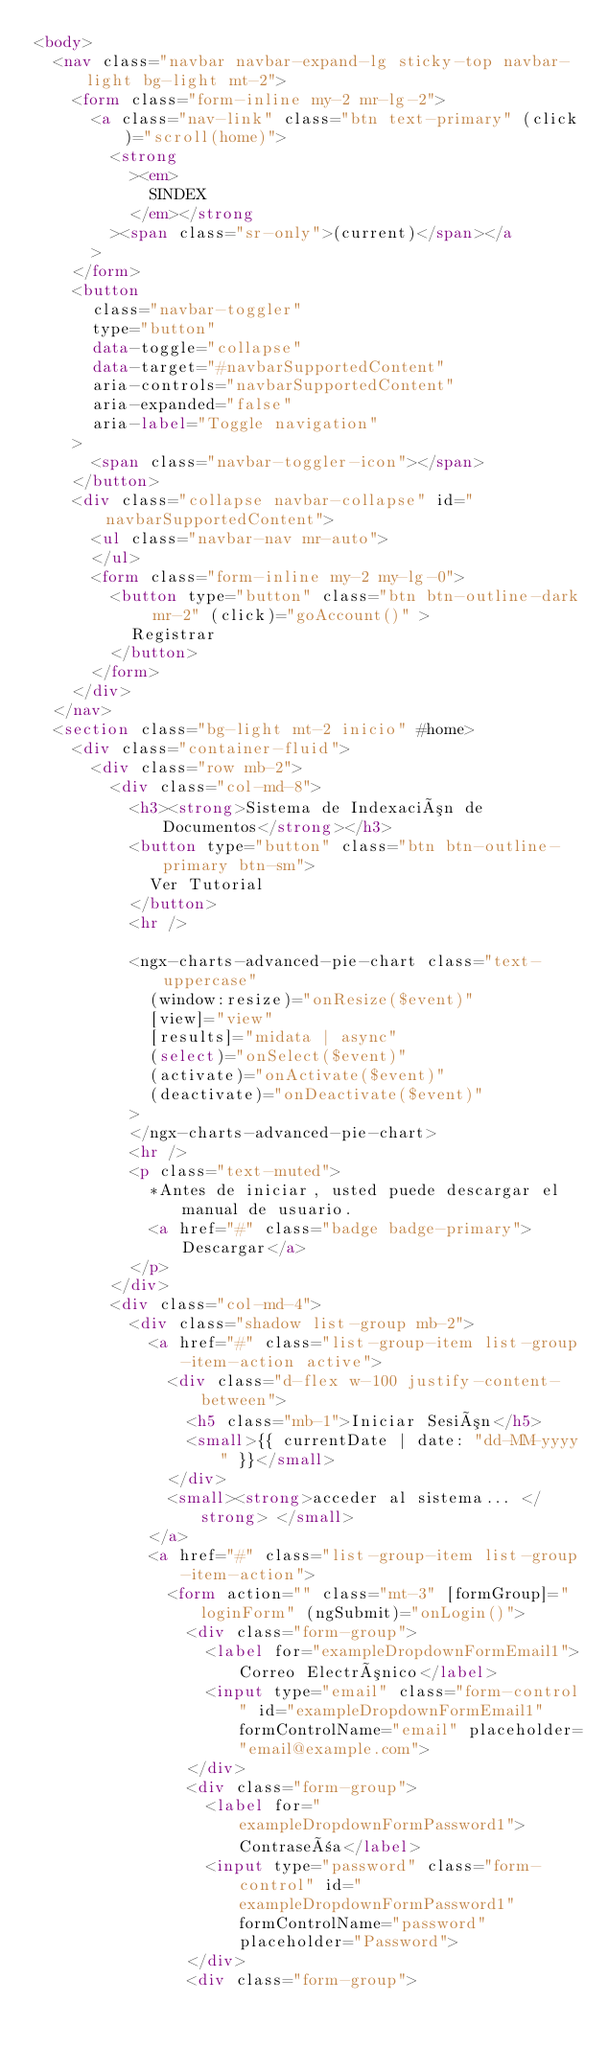Convert code to text. <code><loc_0><loc_0><loc_500><loc_500><_HTML_><body>
  <nav class="navbar navbar-expand-lg sticky-top navbar-light bg-light mt-2">
    <form class="form-inline my-2 mr-lg-2">
      <a class="nav-link" class="btn text-primary" (click)="scroll(home)">
        <strong
          ><em>
            SINDEX
          </em></strong
        ><span class="sr-only">(current)</span></a
      >
    </form>
    <button
      class="navbar-toggler"
      type="button"
      data-toggle="collapse"
      data-target="#navbarSupportedContent"
      aria-controls="navbarSupportedContent"
      aria-expanded="false"
      aria-label="Toggle navigation"
    >
      <span class="navbar-toggler-icon"></span>
    </button>
    <div class="collapse navbar-collapse" id="navbarSupportedContent">
      <ul class="navbar-nav mr-auto">
      </ul>
      <form class="form-inline my-2 my-lg-0">
        <button type="button" class="btn btn-outline-dark mr-2" (click)="goAccount()" >
          Registrar
        </button>
      </form>
    </div>
  </nav>
  <section class="bg-light mt-2 inicio" #home>
    <div class="container-fluid">
      <div class="row mb-2">
        <div class="col-md-8">
          <h3><strong>Sistema de Indexación de Documentos</strong></h3>
          <button type="button" class="btn btn-outline-primary btn-sm">
            Ver Tutorial
          </button>
          <hr />
          
          <ngx-charts-advanced-pie-chart class="text-uppercase"
            (window:resize)="onResize($event)"
            [view]="view"
            [results]="midata | async"
            (select)="onSelect($event)"
            (activate)="onActivate($event)"
            (deactivate)="onDeactivate($event)"
          >
          </ngx-charts-advanced-pie-chart>
          <hr />
          <p class="text-muted">
            *Antes de iniciar, usted puede descargar el manual de usuario.
            <a href="#" class="badge badge-primary">Descargar</a>
          </p>
        </div>
        <div class="col-md-4">
          <div class="shadow list-group mb-2">
            <a href="#" class="list-group-item list-group-item-action active">
              <div class="d-flex w-100 justify-content-between">
                <h5 class="mb-1">Iniciar Sesión</h5>
                <small>{{ currentDate | date: "dd-MM-yyyy" }}</small>
              </div>
              <small><strong>acceder al sistema... </strong> </small>
            </a>
            <a href="#" class="list-group-item list-group-item-action">
              <form action="" class="mt-3" [formGroup]="loginForm" (ngSubmit)="onLogin()">
                <div class="form-group">
                  <label for="exampleDropdownFormEmail1">Correo Electrónico</label>
                  <input type="email" class="form-control" id="exampleDropdownFormEmail1" formControlName="email" placeholder="email@example.com">
                </div>
                <div class="form-group">
                  <label for="exampleDropdownFormPassword1">Contraseña</label>
                  <input type="password" class="form-control" id="exampleDropdownFormPassword1" formControlName="password" placeholder="Password">
                </div>
                <div class="form-group"></code> 